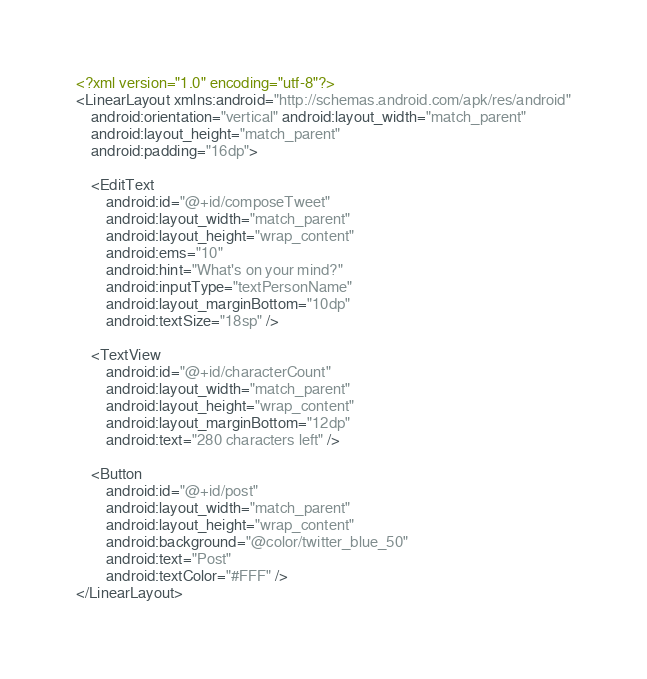<code> <loc_0><loc_0><loc_500><loc_500><_XML_><?xml version="1.0" encoding="utf-8"?>
<LinearLayout xmlns:android="http://schemas.android.com/apk/res/android"
    android:orientation="vertical" android:layout_width="match_parent"
    android:layout_height="match_parent"
    android:padding="16dp">

    <EditText
        android:id="@+id/composeTweet"
        android:layout_width="match_parent"
        android:layout_height="wrap_content"
        android:ems="10"
        android:hint="What's on your mind?"
        android:inputType="textPersonName"
        android:layout_marginBottom="10dp"
        android:textSize="18sp" />

    <TextView
        android:id="@+id/characterCount"
        android:layout_width="match_parent"
        android:layout_height="wrap_content"
        android:layout_marginBottom="12dp"
        android:text="280 characters left" />

    <Button
        android:id="@+id/post"
        android:layout_width="match_parent"
        android:layout_height="wrap_content"
        android:background="@color/twitter_blue_50"
        android:text="Post"
        android:textColor="#FFF" />
</LinearLayout></code> 